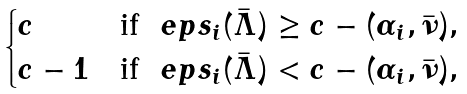Convert formula to latex. <formula><loc_0><loc_0><loc_500><loc_500>\begin{cases} c & \text {if } \ e p s _ { i } ( \bar { \Lambda } ) \geq c - ( \alpha _ { i } , \bar { \nu } ) , \\ c - 1 & \text {if } \ e p s _ { i } ( \bar { \Lambda } ) < c - ( \alpha _ { i } , \bar { \nu } ) , \end{cases}</formula> 